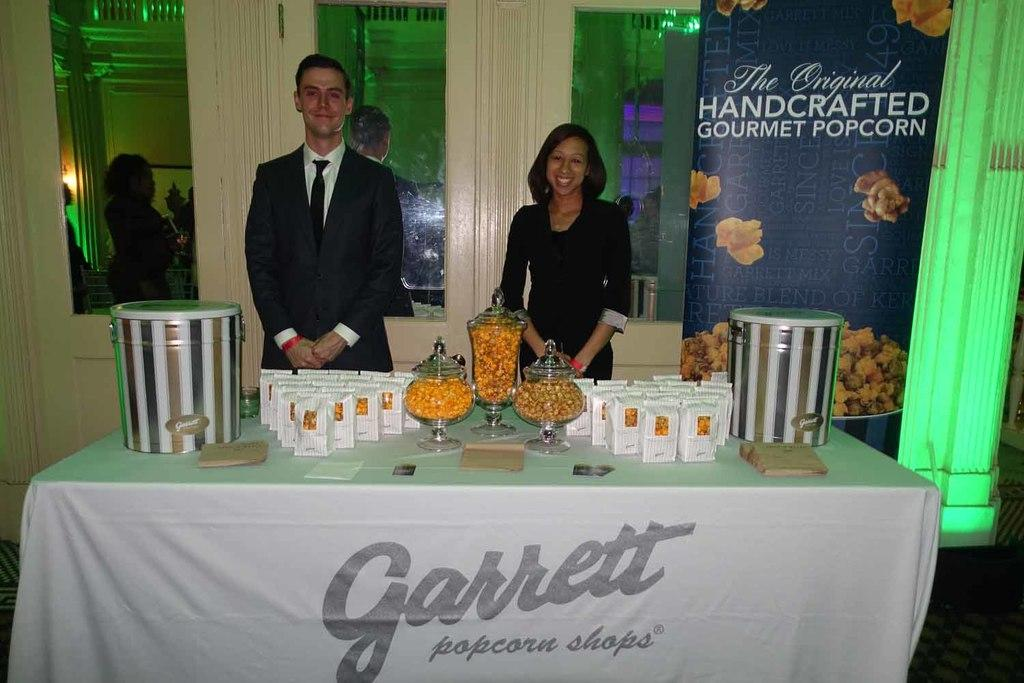How many people are in the image? There are two persons standing in the image. What is the facial expression of the persons? The persons are smiling. What is present on the table in the image? There is a container and food packets on the table. What can be seen hanging in the image? There is a banner in the image. Is there any reflection visible in the image? Yes, there is a reflection of persons on a glass. How many trees are visible in the image? There are no trees visible in the image. What color is the rose on the table? There is no rose present in the image. 